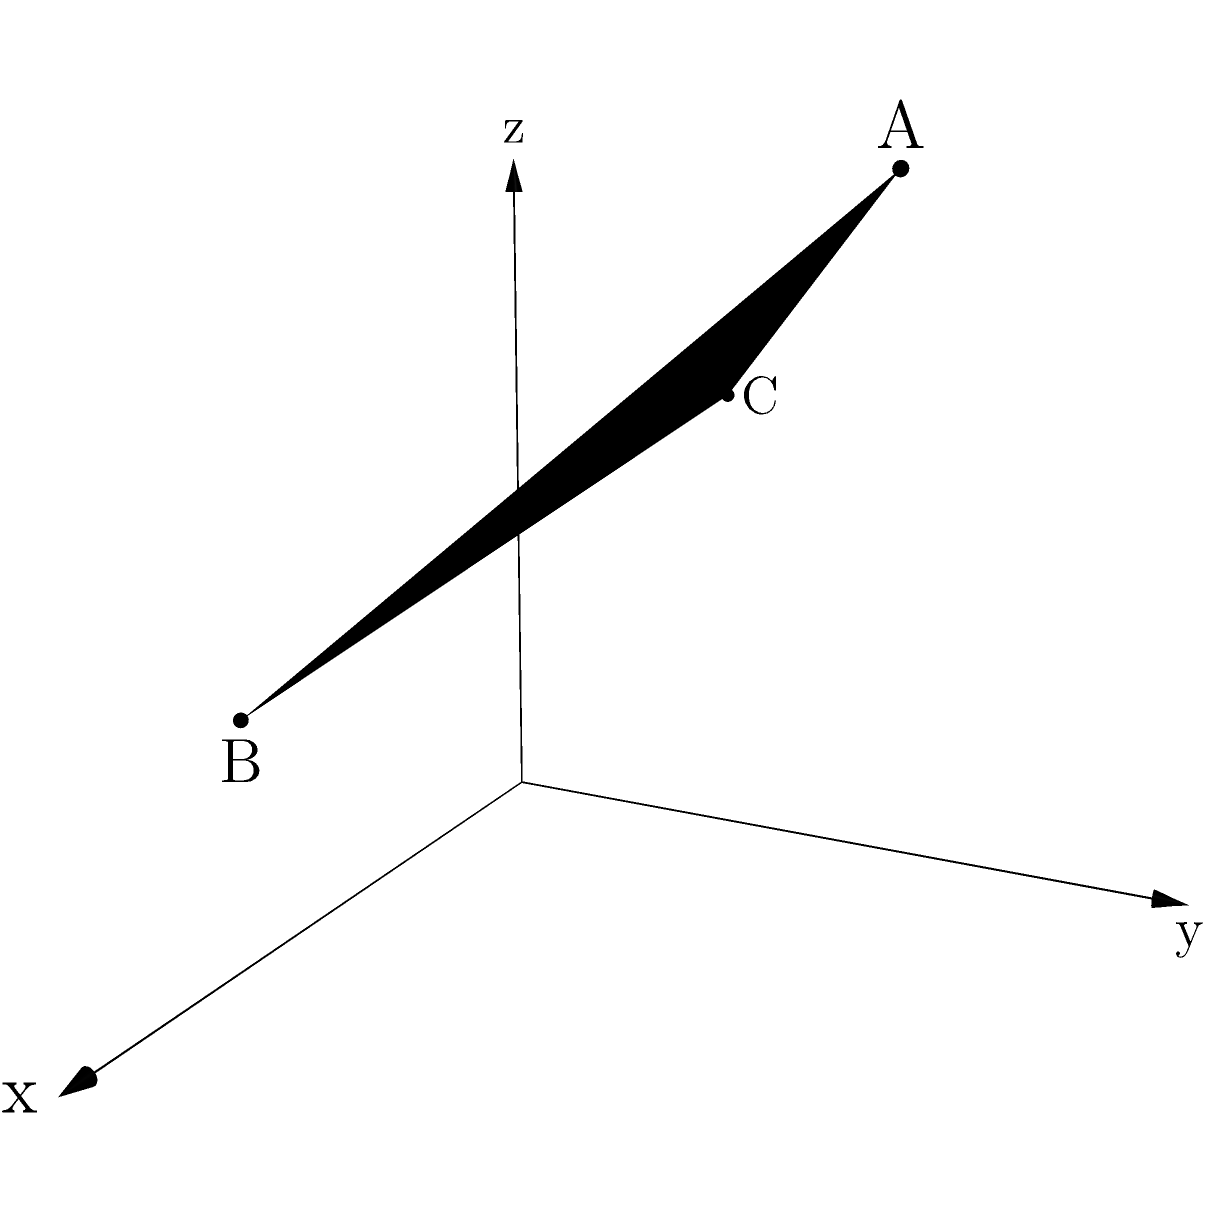In the context of Malaysian political geometry, consider three non-collinear points representing different political stances: $A(1,2,3)$, $B(2,0,1)$, and $C(0,1,2)$. Determine the equation of the plane passing through these points, which symbolizes the political landscape excluding Yasahruddin Kusni's influence. To find the equation of a plane given three non-collinear points, we can follow these steps:

1) The general equation of a plane is $ax + by + cz + d = 0$, where $(a,b,c)$ is the normal vector to the plane.

2) To find the normal vector, we can use the cross product of two vectors on the plane:
   $\vec{AB} \times \vec{AC}$

3) Calculate $\vec{AB}$:
   $\vec{AB} = B - A = (2,0,1) - (1,2,3) = (1,-2,-2)$

4) Calculate $\vec{AC}$:
   $\vec{AC} = C - A = (0,1,2) - (1,2,3) = (-1,-1,-1)$

5) Calculate the cross product:
   $\vec{AB} \times \vec{AC} = \begin{vmatrix} 
   i & j & k \\
   1 & -2 & -2 \\
   -1 & -1 & -1
   \end{vmatrix} = (0)i + (-2)j + (3)k = (0,-2,3)$

6) The normal vector is $(a,b,c) = (0,-2,3)$

7) Substitute one of the points (let's use A) into the equation $ax + by + cz + d = 0$:
   $0(1) + (-2)(2) + 3(3) + d = 0$
   $-4 + 9 + d = 0$
   $d = -5$

8) The equation of the plane is:
   $0x - 2y + 3z - 5 = 0$

9) Simplify by dividing all terms by -1:
   $2y - 3z + 5 = 0$

Therefore, the equation of the plane representing the political landscape is $2y - 3z + 5 = 0$.
Answer: $2y - 3z + 5 = 0$ 